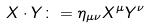<formula> <loc_0><loc_0><loc_500><loc_500>X \cdot Y \colon = \eta _ { \mu \nu } X ^ { \mu } Y ^ { \nu }</formula> 